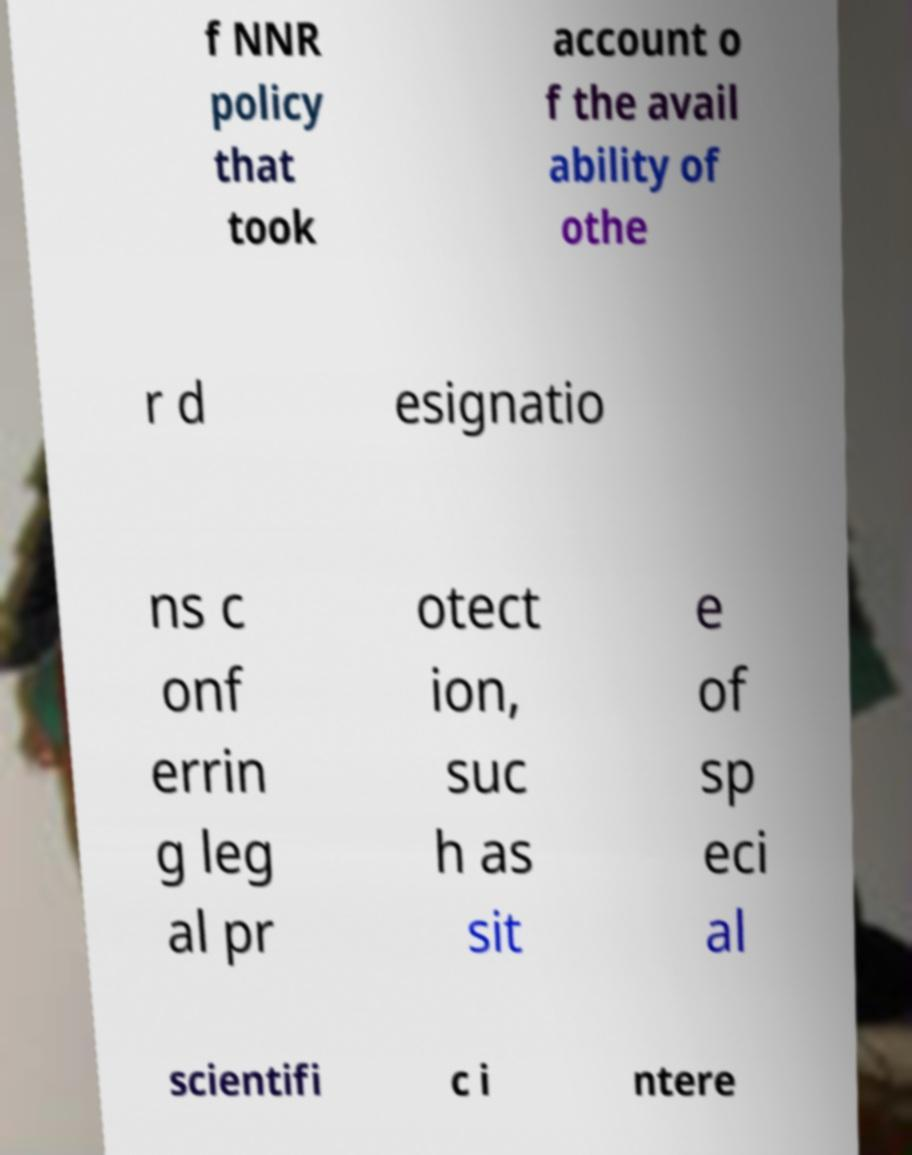For documentation purposes, I need the text within this image transcribed. Could you provide that? f NNR policy that took account o f the avail ability of othe r d esignatio ns c onf errin g leg al pr otect ion, suc h as sit e of sp eci al scientifi c i ntere 